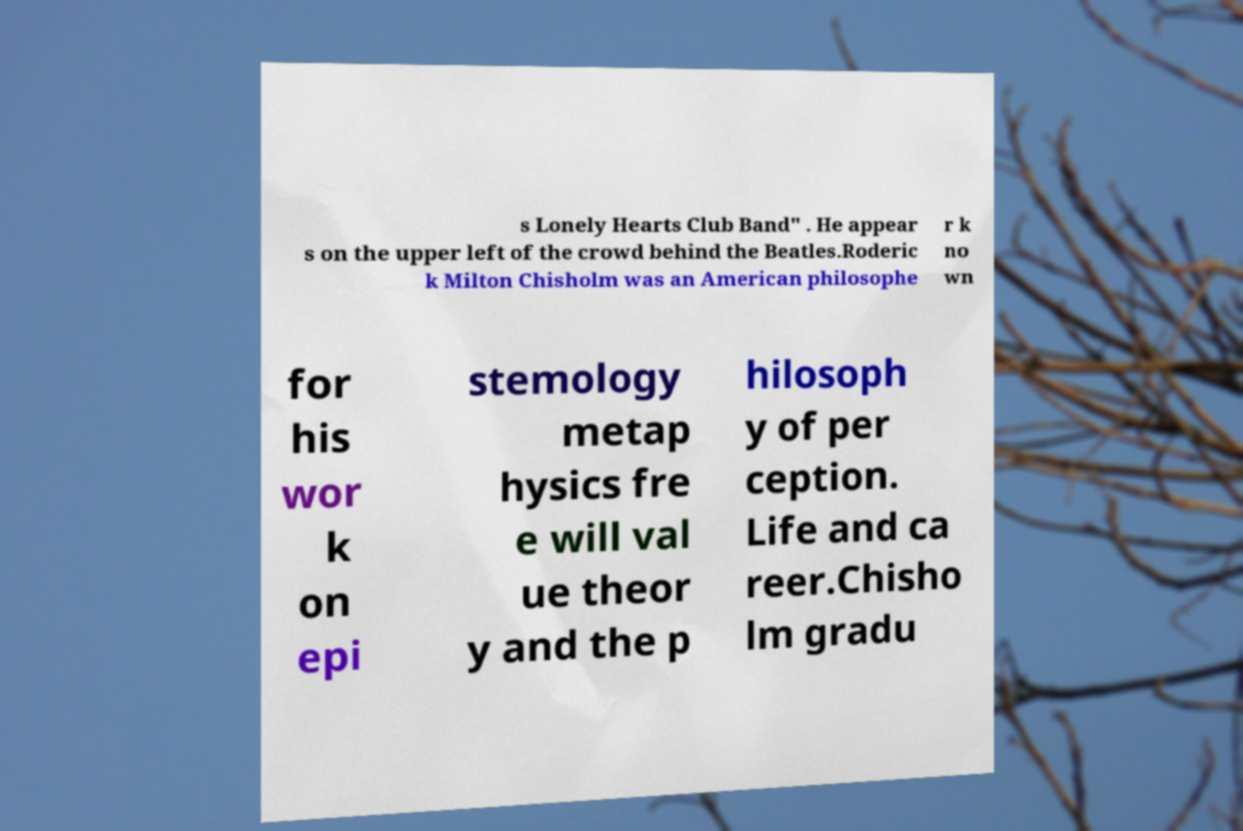I need the written content from this picture converted into text. Can you do that? s Lonely Hearts Club Band" . He appear s on the upper left of the crowd behind the Beatles.Roderic k Milton Chisholm was an American philosophe r k no wn for his wor k on epi stemology metap hysics fre e will val ue theor y and the p hilosoph y of per ception. Life and ca reer.Chisho lm gradu 